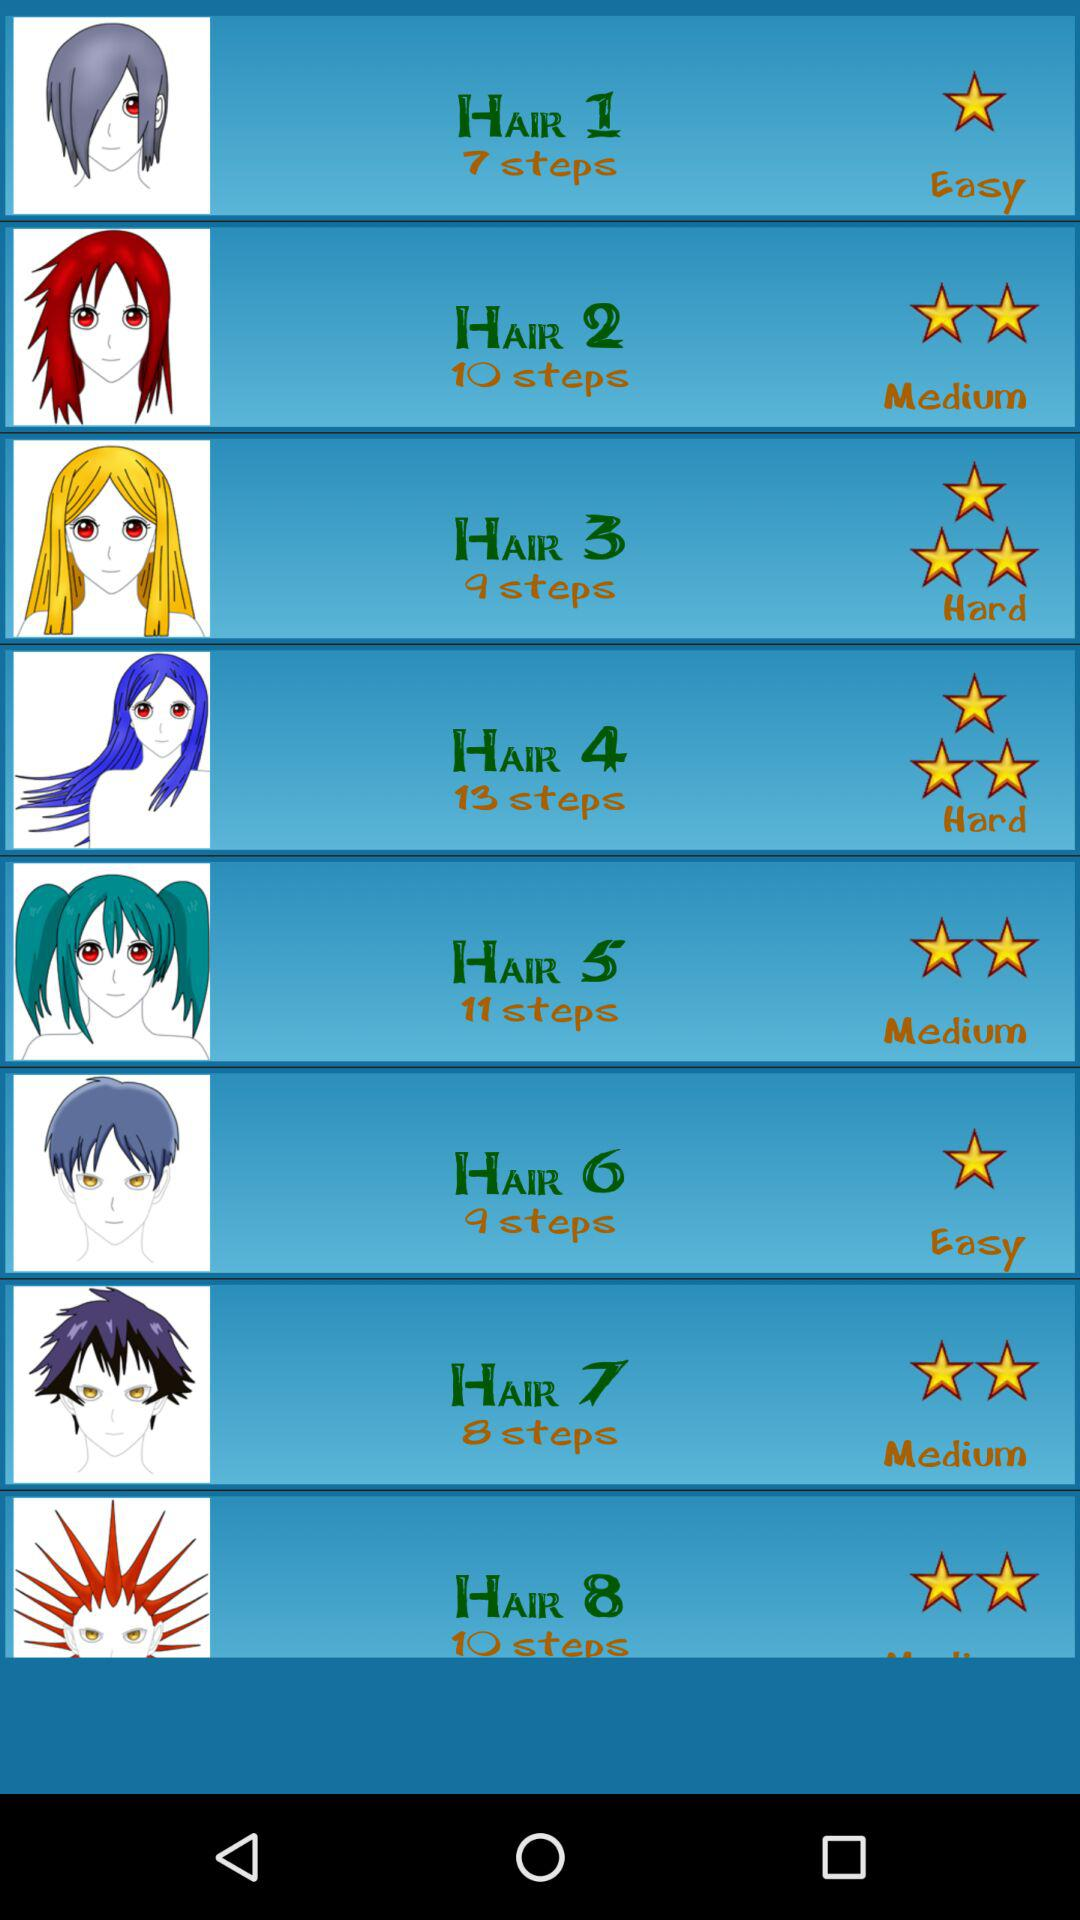How many steps are there in "HAIR 3"? There are 9 steps in "HAIR 3". 